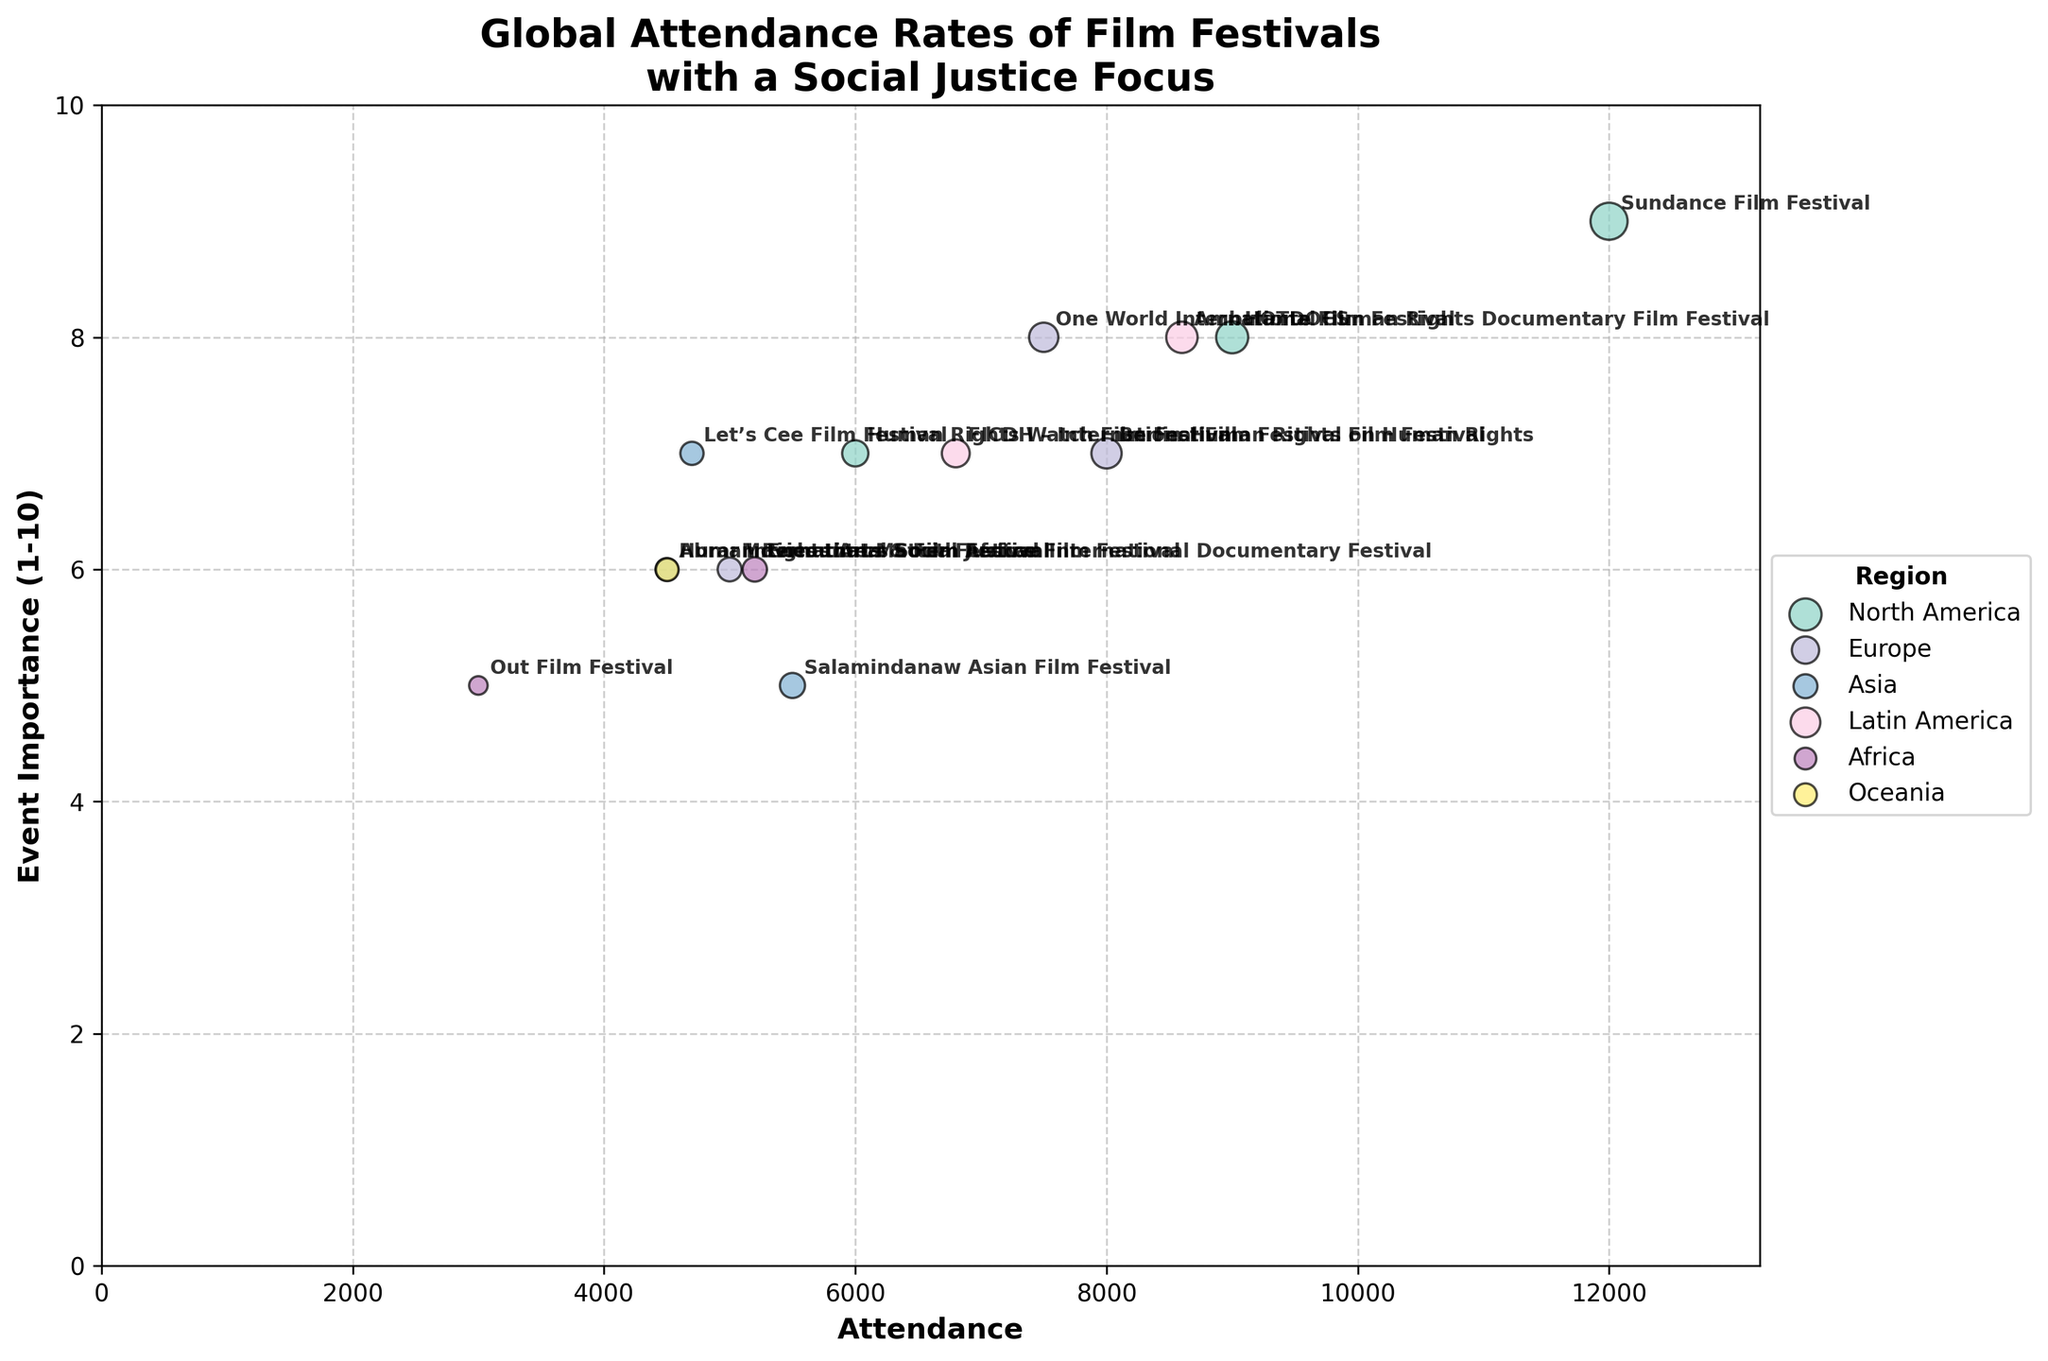What's the title of the figure? The title is usually at the top of the figure. In this case, it reads "Global Attendance Rates of Film Festivals with a Social Justice Focus".
Answer: Global Attendance Rates of Film Festivals with a Social Justice Focus Which region has the highest attendance film festival? The largest bubble (indicating the highest attendance) is found in North America for the Sundance Film Festival with an attendance of 12000.
Answer: North America How many film festivals have an attendance greater than 8000? There are four film festivals with attendance greater than 8000: Sundance Film Festival (12000), HOTDOCS (9000), Ambulante Film Festival (8600), and Berlin Human Rights Film Festival (8000).
Answer: 4 Which film festival has the lowest attendance and what region is it in? The smallest bubble (indicating the lowest attendance) is found in Africa for the Out Film Festival with an attendance of 3000.
Answer: Out Film Festival in Africa Comparing Europe and Asia, which region has a higher average event importance? First, calculate the average event importance for Europe: (7+8+6)/3 = 7. For Asia: (6+7+5)/3 = 6. Hence, Europe has a higher average event importance.
Answer: Europe What is the range of attendance values for Latin American film festivals? Latin America has two film festivals: Ambulante Film Festival (8600) and FICDH – International Film Festival on Human Rights (6800). The range is 8600 - 6800 = 1800.
Answer: 1800 Identify a film festival in Europe with an event importance of 8. There is one film festival in Europe with an event importance of 8, which is the One World International Human Rights Documentary Film Festival.
Answer: One World International Human Rights Documentary Film Festival Which film festival has the same event importance as the Movies that Matter Festival, but a higher attendance? The Movies that Matter Festival has an event importance of 6. Checking other festivals with an event importance of 6 reveals that the one with a higher attendance is Encounters South African International Documentary Festival (5200 vs. 5000).
Answer: Encounters South African International Documentary Festival What's the most common event importance value among the festivals? The values of event importance for each festival are: 9, 8, 7, 7, 8, 6, 6, 7, 5, 7, 8, 6, 5, 6. The mode (most common value) here is 6.
Answer: 6 What is the mean attendance of the film festivals in North America? North America's festivals have attendance: 12000 (Sundance Film Festival), 9000 (HOTDOCS), and 6000 (Human Rights Watch Film Festival). The mean is calculated by (12000 + 9000 + 6000) / 3 = 9000.
Answer: 9000 